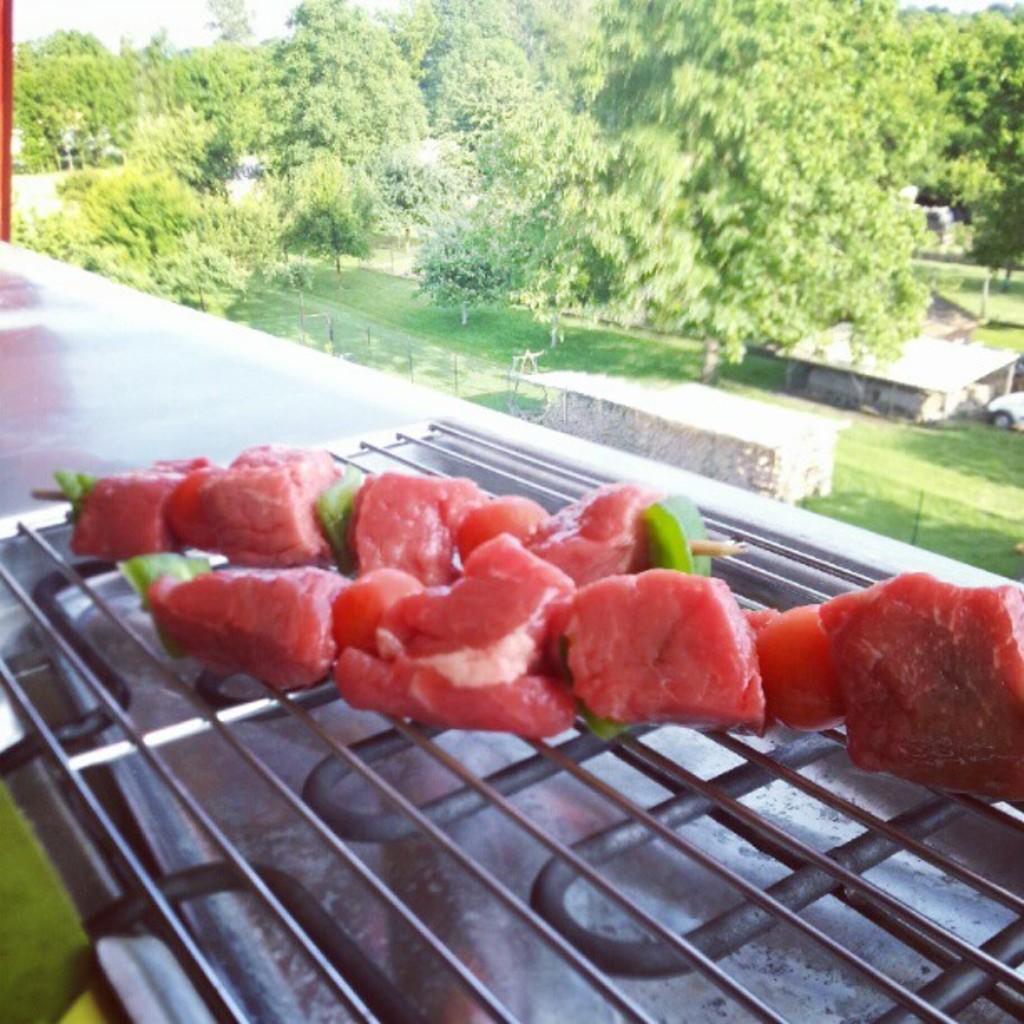Could you give a brief overview of what you see in this image? Here we can see food on grills. Background we can see trees and grass. 